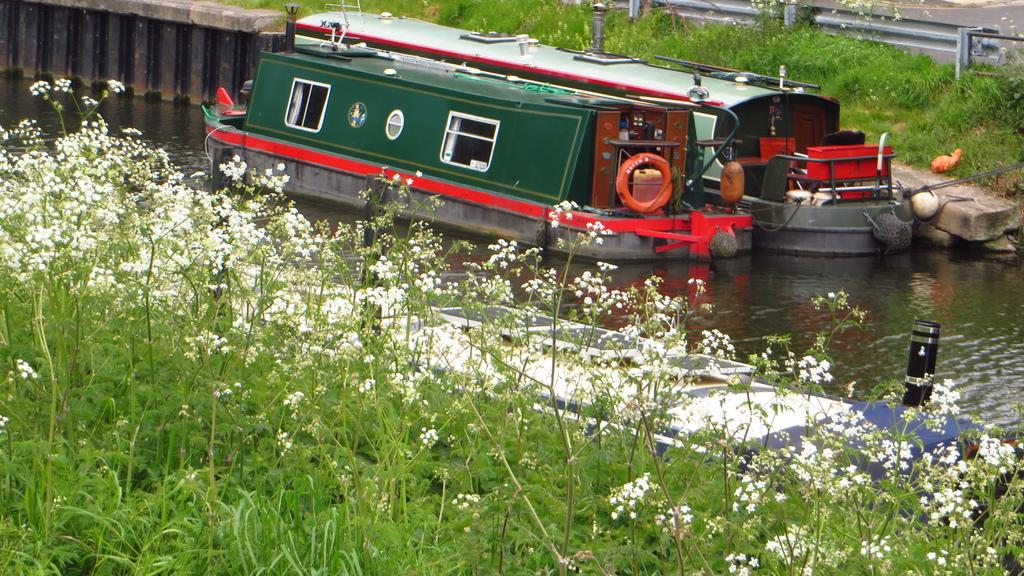What is on the water in the image? There are boats on the water in the image. What can be seen in the background of the image? In the background of the image, there is a railing, a road, plants, flowers, and a wall. Can you describe the vegetation in the background of the image? The vegetation in the background of the image includes plants and flowers. What song is the grandmother singing in the image? There is no grandmother or song present in the image. 